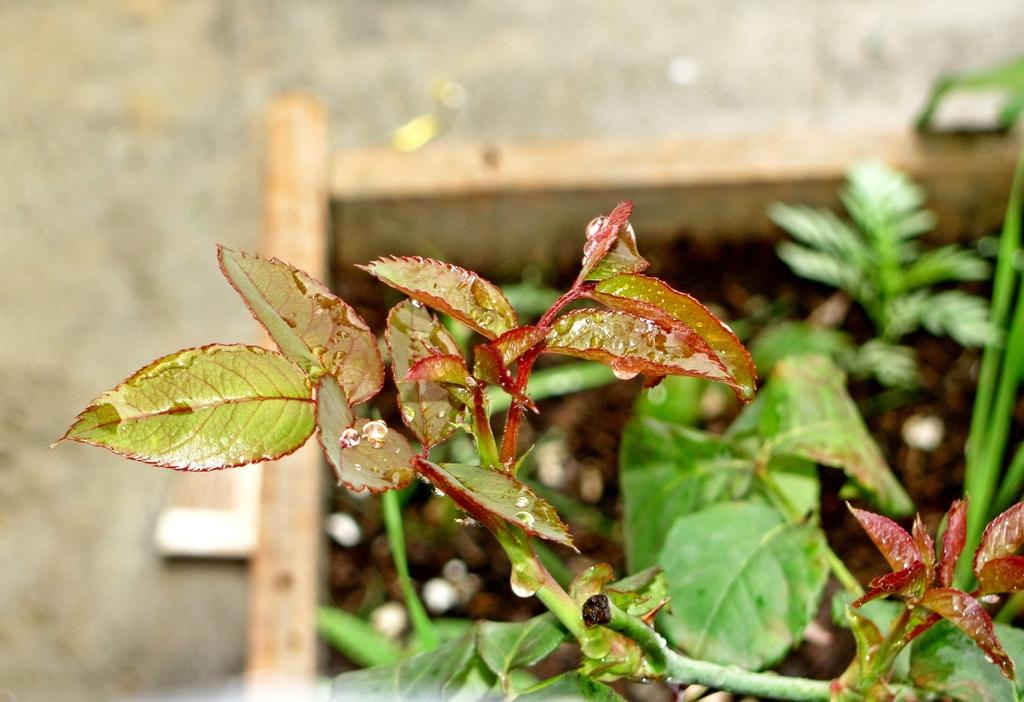What is located at the bottom of the image? There are plants at the bottom of the image. Can you describe the background of the image? The background of the image is blurred. What is the cause of the partner's disagreement in the image? There is no partner or disagreement present in the image; it features plants at the bottom and a blurred background. 